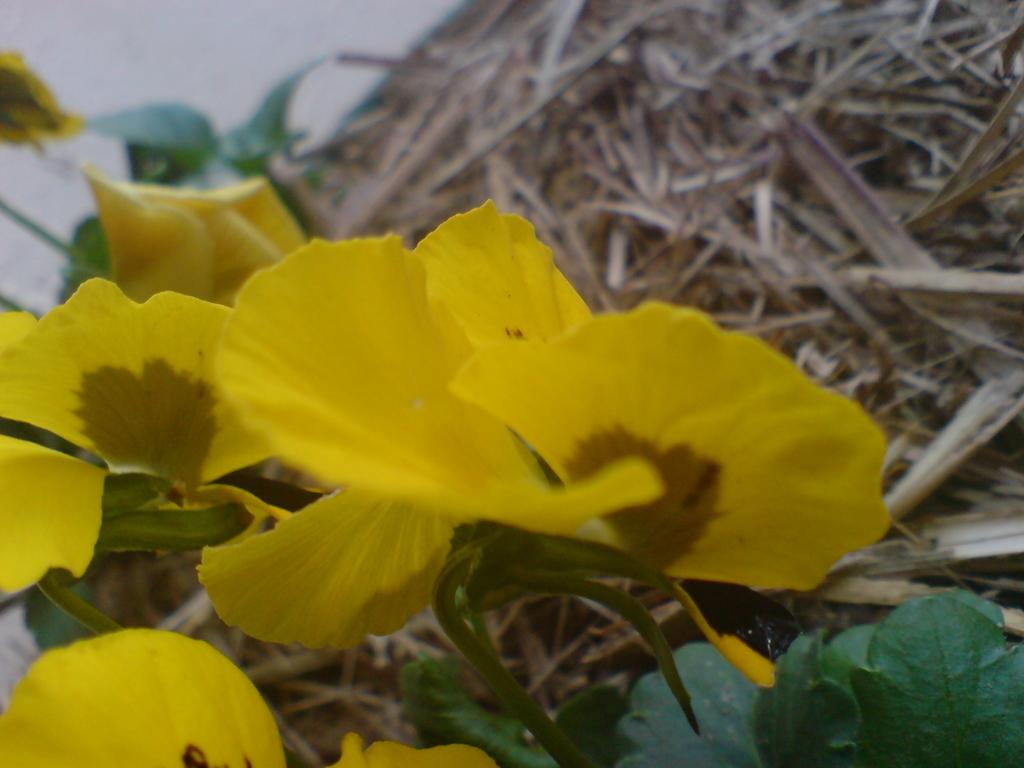What is the main subject of the image? The main subject of the image is a group of flowers. Can you describe the flowers in more detail? The flowers are on the stem of a plant. What type of friction can be observed between the flowers and the stem in the image? There is no friction between the flowers and the stem in the image, as the flowers are naturally attached to the stem. 